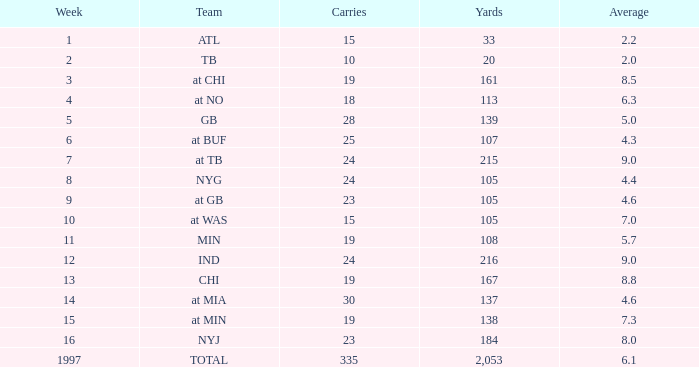Which Yards have Carries smaller than 23, and a Team of at chi, and an Average smaller than 8.5? None. 